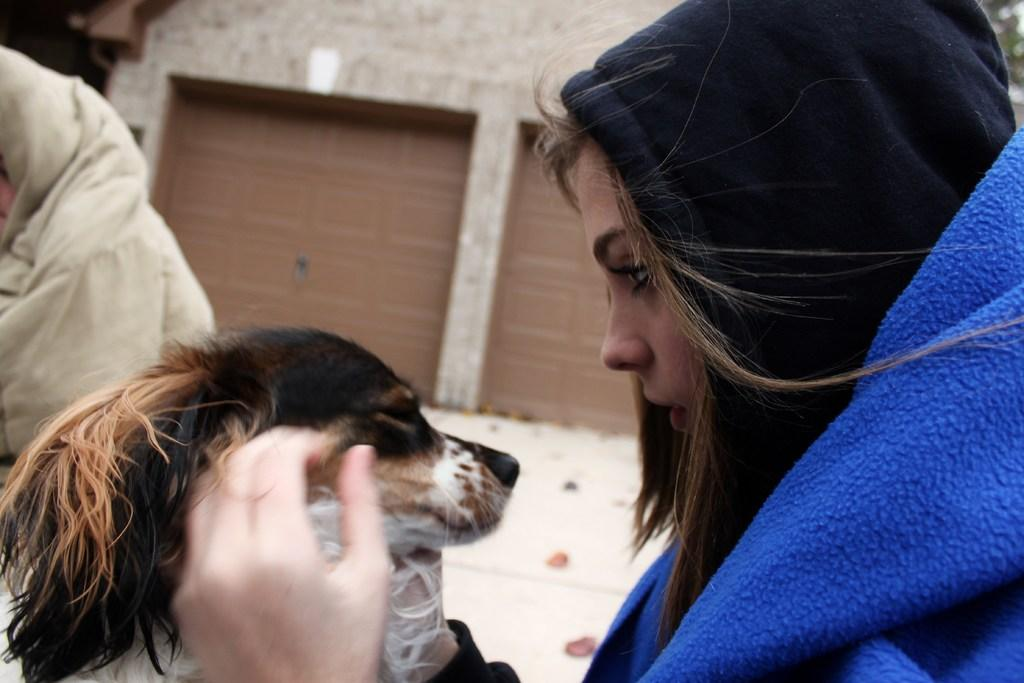Who is present in the image? There is a woman in the image. What other living creature can be seen in the image? There is a dog in the image. How many jellyfish are swimming in the background of the image? There are no jellyfish present in the image; it features a woman and a dog. What type of thread is being used by the woman in the image? There is no thread visible in the image, as it only features a woman and a dog. 